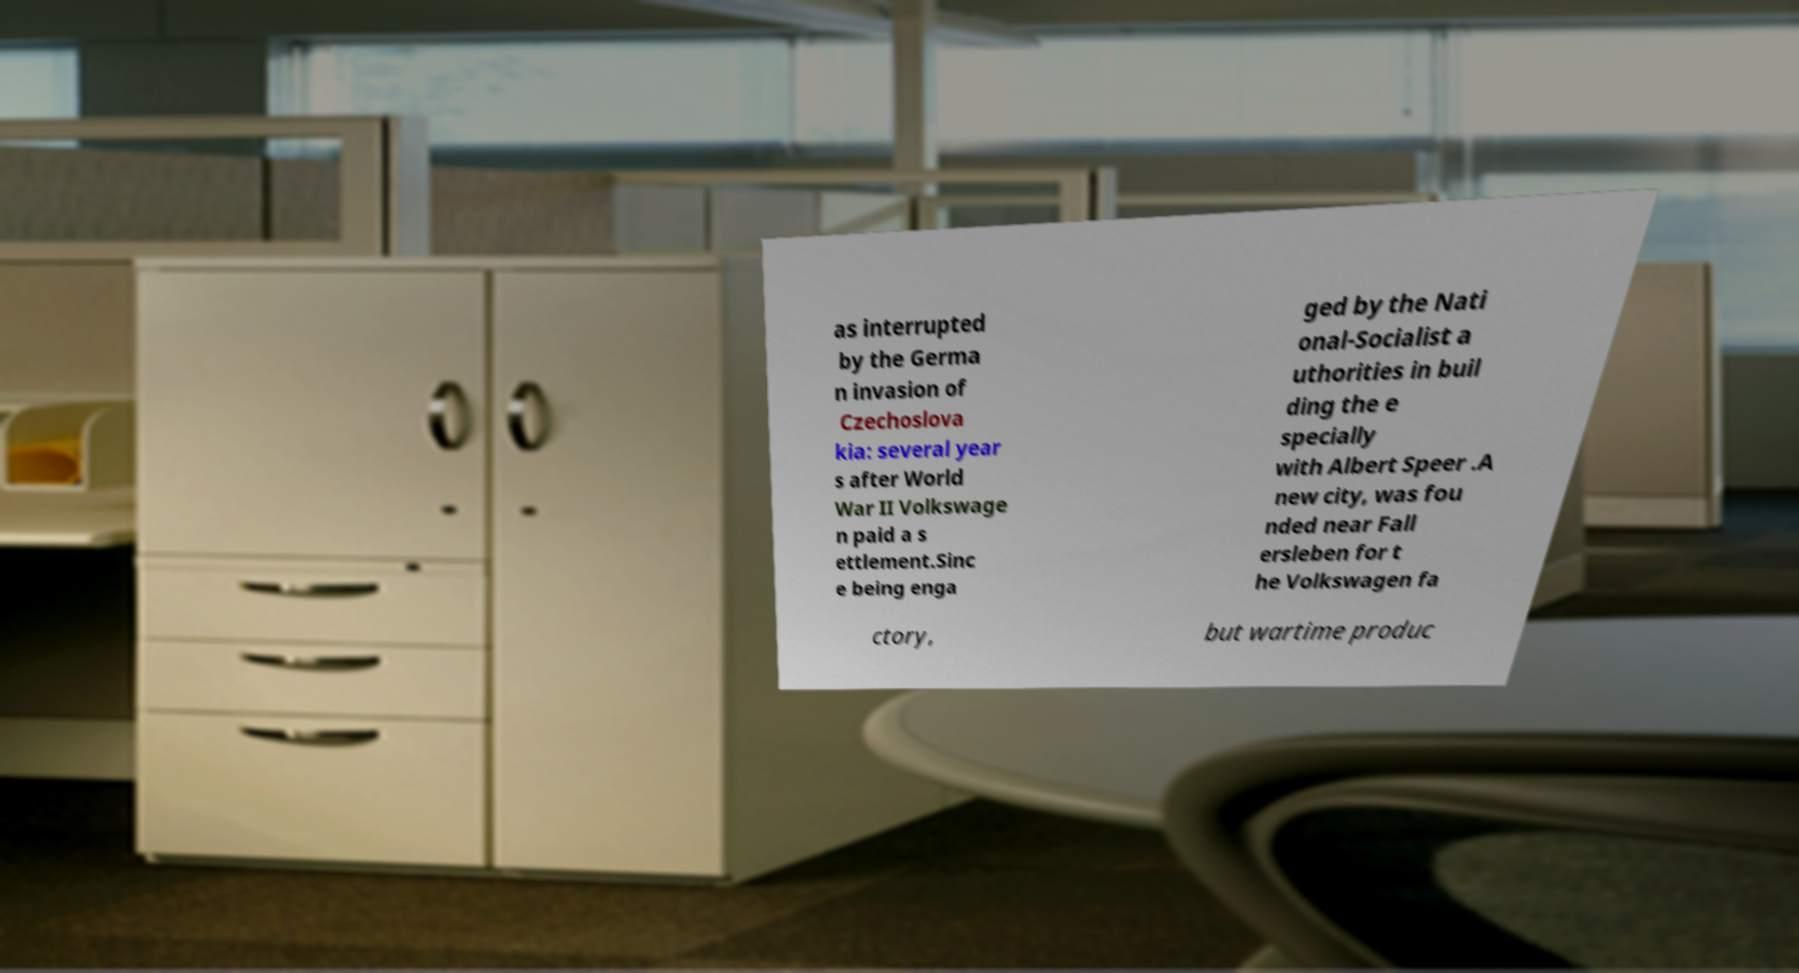Please read and relay the text visible in this image. What does it say? as interrupted by the Germa n invasion of Czechoslova kia: several year s after World War II Volkswage n paid a s ettlement.Sinc e being enga ged by the Nati onal-Socialist a uthorities in buil ding the e specially with Albert Speer .A new city, was fou nded near Fall ersleben for t he Volkswagen fa ctory, but wartime produc 